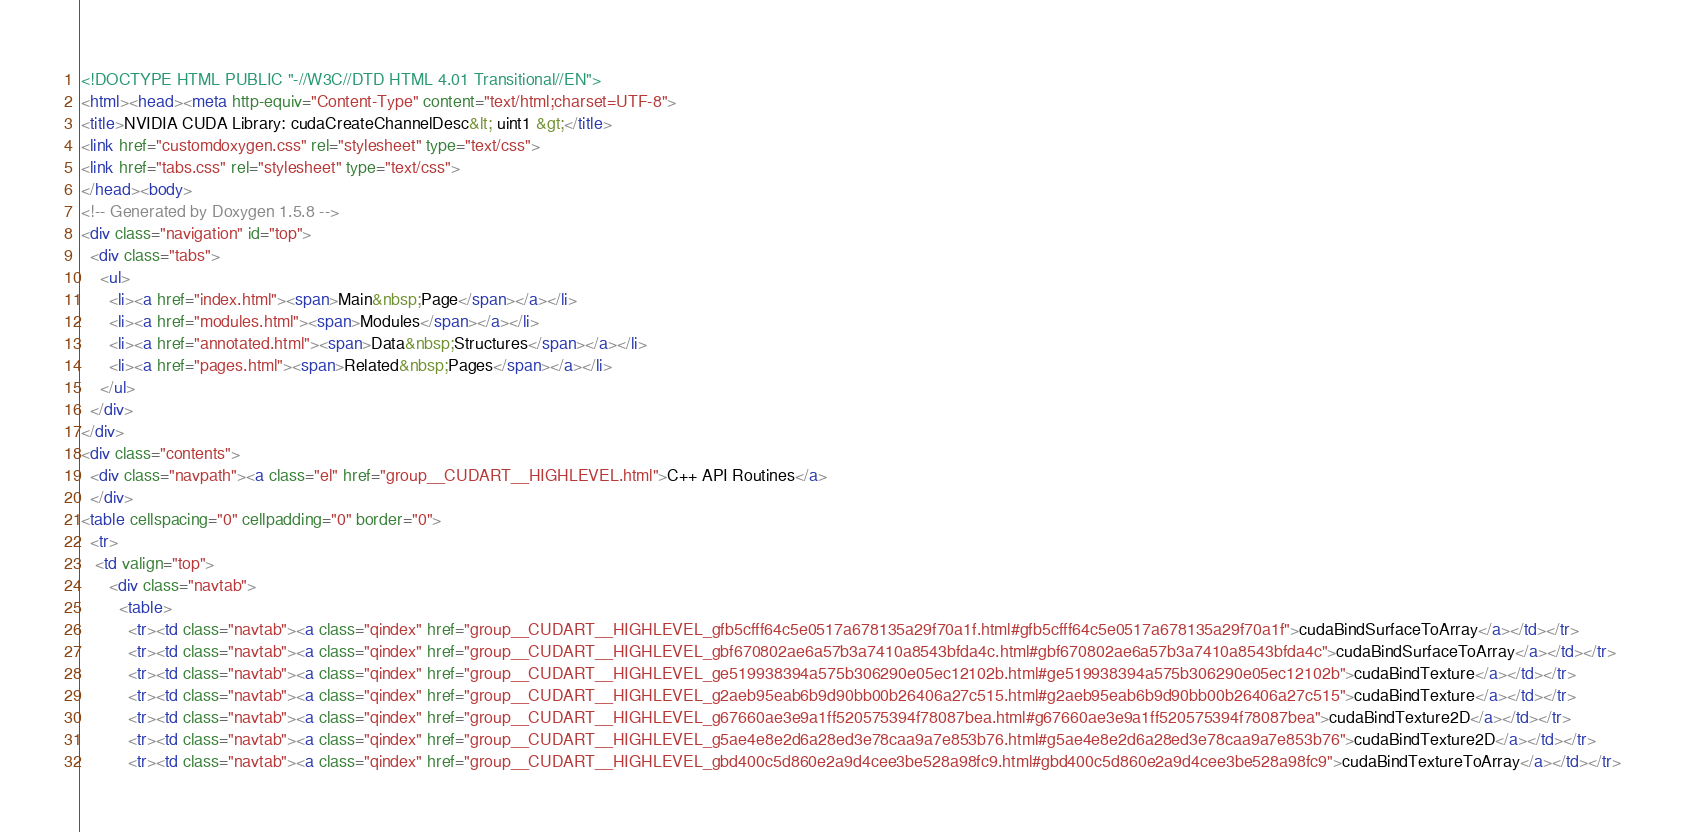<code> <loc_0><loc_0><loc_500><loc_500><_HTML_><!DOCTYPE HTML PUBLIC "-//W3C//DTD HTML 4.01 Transitional//EN">
<html><head><meta http-equiv="Content-Type" content="text/html;charset=UTF-8">
<title>NVIDIA CUDA Library: cudaCreateChannelDesc&lt; uint1 &gt;</title>
<link href="customdoxygen.css" rel="stylesheet" type="text/css">
<link href="tabs.css" rel="stylesheet" type="text/css">
</head><body>
<!-- Generated by Doxygen 1.5.8 -->
<div class="navigation" id="top">
  <div class="tabs">
    <ul>
      <li><a href="index.html"><span>Main&nbsp;Page</span></a></li>
      <li><a href="modules.html"><span>Modules</span></a></li>
      <li><a href="annotated.html"><span>Data&nbsp;Structures</span></a></li>
      <li><a href="pages.html"><span>Related&nbsp;Pages</span></a></li>
    </ul>
  </div>
</div>
<div class="contents">
  <div class="navpath"><a class="el" href="group__CUDART__HIGHLEVEL.html">C++ API Routines</a>
  </div>
<table cellspacing="0" cellpadding="0" border="0">
  <tr>
   <td valign="top">
      <div class="navtab">
        <table>
          <tr><td class="navtab"><a class="qindex" href="group__CUDART__HIGHLEVEL_gfb5cfff64c5e0517a678135a29f70a1f.html#gfb5cfff64c5e0517a678135a29f70a1f">cudaBindSurfaceToArray</a></td></tr>
          <tr><td class="navtab"><a class="qindex" href="group__CUDART__HIGHLEVEL_gbf670802ae6a57b3a7410a8543bfda4c.html#gbf670802ae6a57b3a7410a8543bfda4c">cudaBindSurfaceToArray</a></td></tr>
          <tr><td class="navtab"><a class="qindex" href="group__CUDART__HIGHLEVEL_ge519938394a575b306290e05ec12102b.html#ge519938394a575b306290e05ec12102b">cudaBindTexture</a></td></tr>
          <tr><td class="navtab"><a class="qindex" href="group__CUDART__HIGHLEVEL_g2aeb95eab6b9d90bb00b26406a27c515.html#g2aeb95eab6b9d90bb00b26406a27c515">cudaBindTexture</a></td></tr>
          <tr><td class="navtab"><a class="qindex" href="group__CUDART__HIGHLEVEL_g67660ae3e9a1ff520575394f78087bea.html#g67660ae3e9a1ff520575394f78087bea">cudaBindTexture2D</a></td></tr>
          <tr><td class="navtab"><a class="qindex" href="group__CUDART__HIGHLEVEL_g5ae4e8e2d6a28ed3e78caa9a7e853b76.html#g5ae4e8e2d6a28ed3e78caa9a7e853b76">cudaBindTexture2D</a></td></tr>
          <tr><td class="navtab"><a class="qindex" href="group__CUDART__HIGHLEVEL_gbd400c5d860e2a9d4cee3be528a98fc9.html#gbd400c5d860e2a9d4cee3be528a98fc9">cudaBindTextureToArray</a></td></tr></code> 